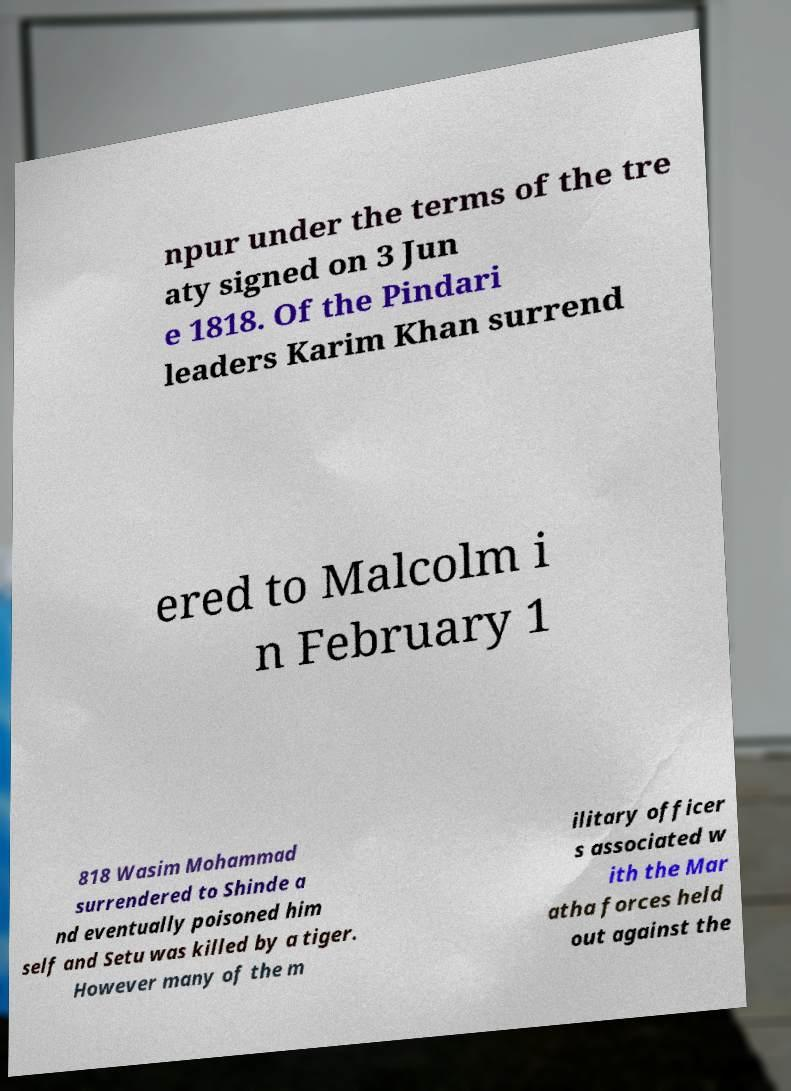Can you read and provide the text displayed in the image?This photo seems to have some interesting text. Can you extract and type it out for me? npur under the terms of the tre aty signed on 3 Jun e 1818. Of the Pindari leaders Karim Khan surrend ered to Malcolm i n February 1 818 Wasim Mohammad surrendered to Shinde a nd eventually poisoned him self and Setu was killed by a tiger. However many of the m ilitary officer s associated w ith the Mar atha forces held out against the 